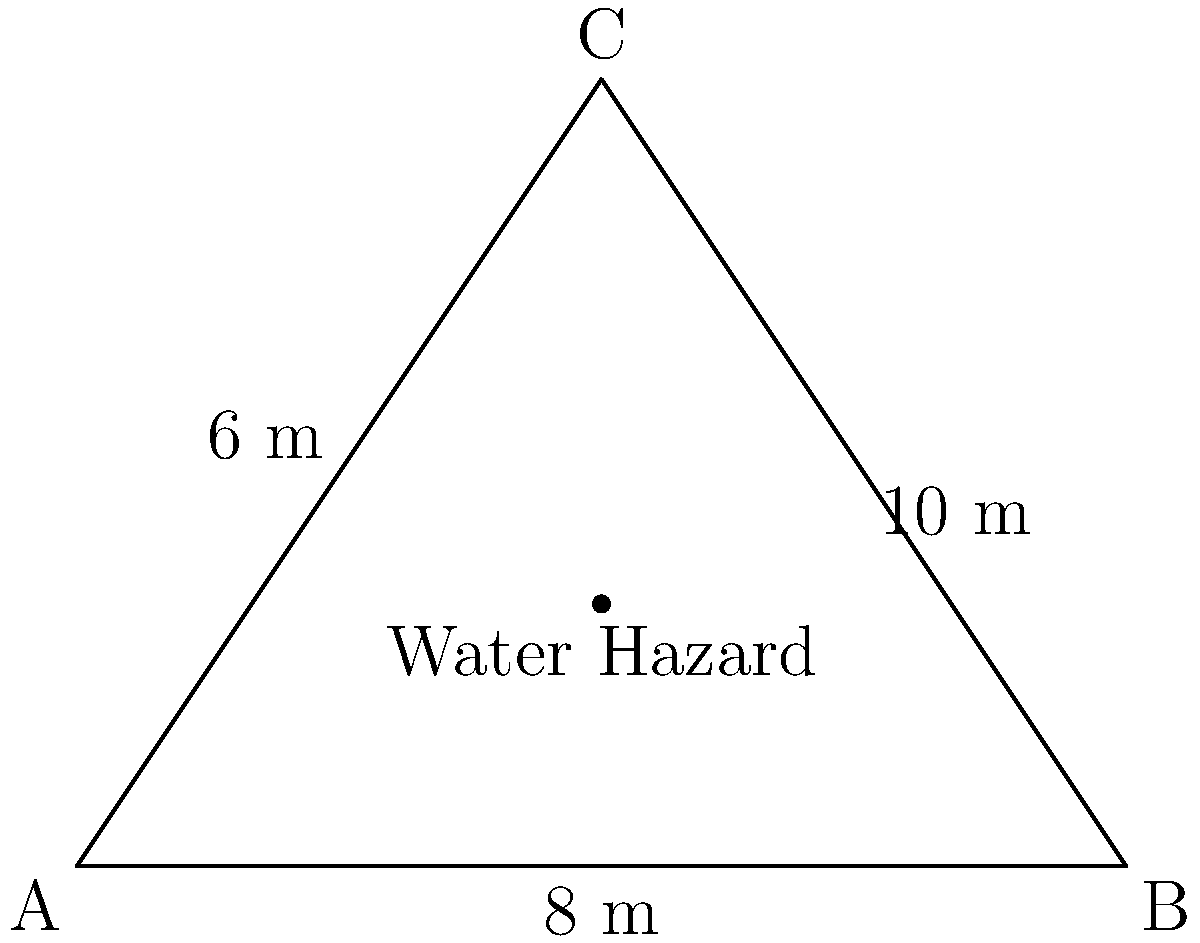At the Daio Paper Elleair Ladies Open in Ehime Prefecture, a triangular water hazard on the course has sides measuring 6 m, 8 m, and 10 m. What is the area of this water hazard? To find the area of the triangular water hazard, we can use Heron's formula:

1) Heron's formula states that the area $A$ of a triangle with sides $a$, $b$, and $c$ is:

   $A = \sqrt{s(s-a)(s-b)(s-c)}$

   where $s$ is the semi-perimeter: $s = \frac{a+b+c}{2}$

2) In this case, $a = 6$ m, $b = 8$ m, and $c = 10$ m

3) Calculate the semi-perimeter:
   $s = \frac{6+8+10}{2} = \frac{24}{2} = 12$ m

4) Now, substitute these values into Heron's formula:

   $A = \sqrt{12(12-6)(12-8)(12-10)}$
   $= \sqrt{12 \cdot 6 \cdot 4 \cdot 2}$
   $= \sqrt{576}$
   $= 24$ m²

Therefore, the area of the triangular water hazard is 24 square meters.
Answer: 24 m² 